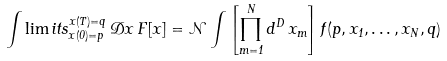<formula> <loc_0><loc_0><loc_500><loc_500>\int \lim i t s _ { x ( 0 ) = p } ^ { x ( T ) = q } \, \mathcal { D } x \, F [ x ] = \mathcal { N } \int \left [ \prod _ { m = 1 } ^ { N } d ^ { D } \, x _ { m } \right ] f ( p , x _ { 1 } , \dots , x _ { N } , q )</formula> 